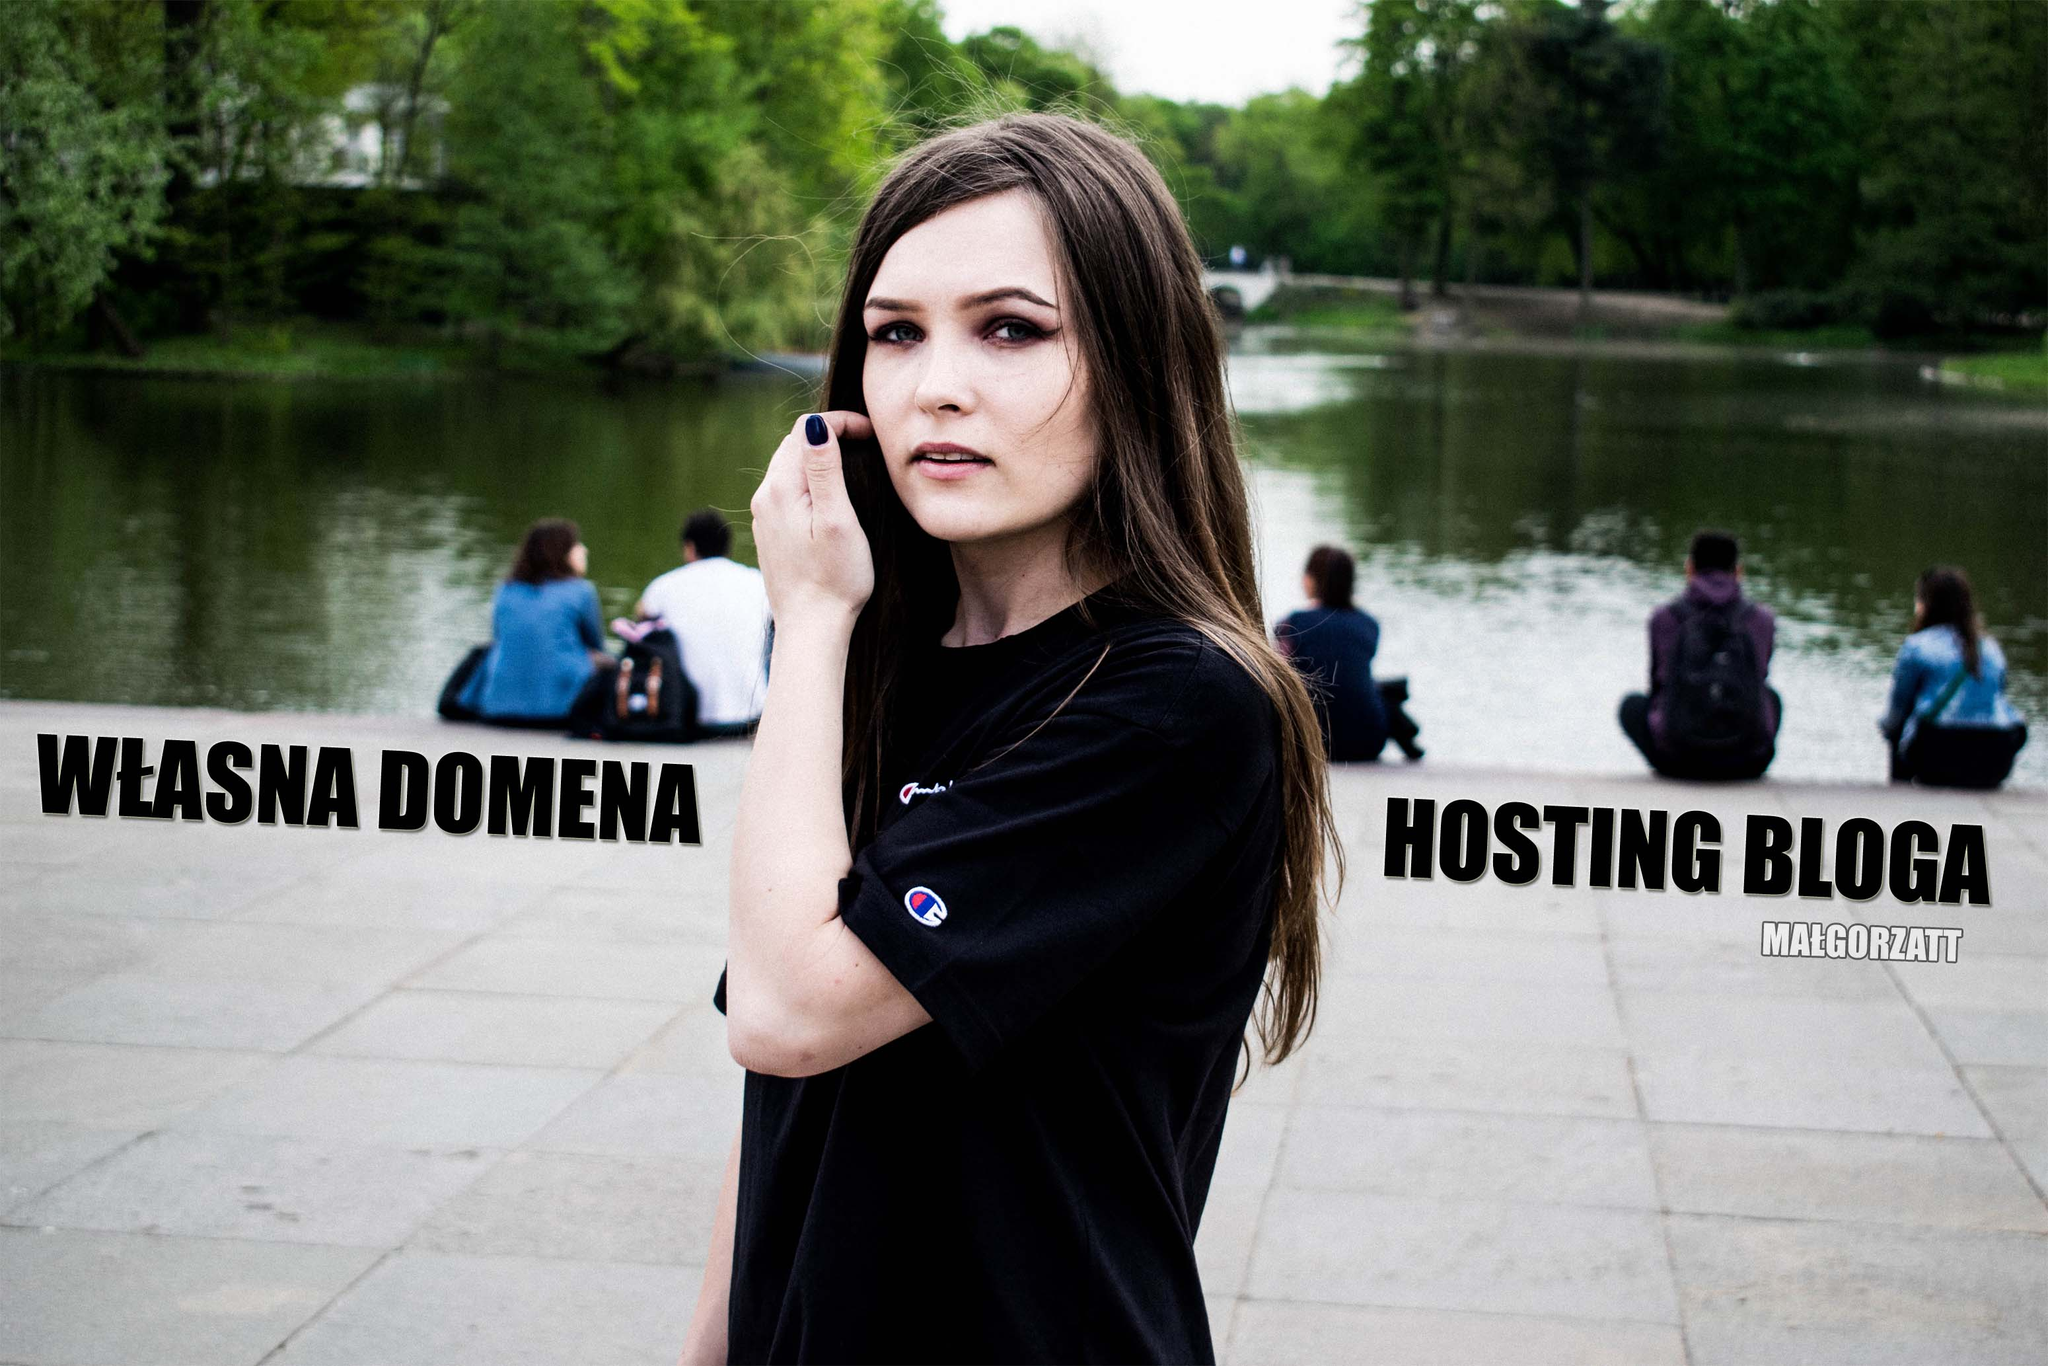What are the possible uses of the text seen in the image within different contexts? The text 'WŁASNA DOMENA' and 'HOSTING BLOGA' can be used in various contexts. In a commercial setting, it could be part of an advertisement for a web hosting company. In an educational context, it might be used in materials teaching website development. Additionally, if this image were part of a blog post about starting a blog, the text could represent important steps in the blogging process. Its versatility makes it applicable in numerous digital and print media environments. 